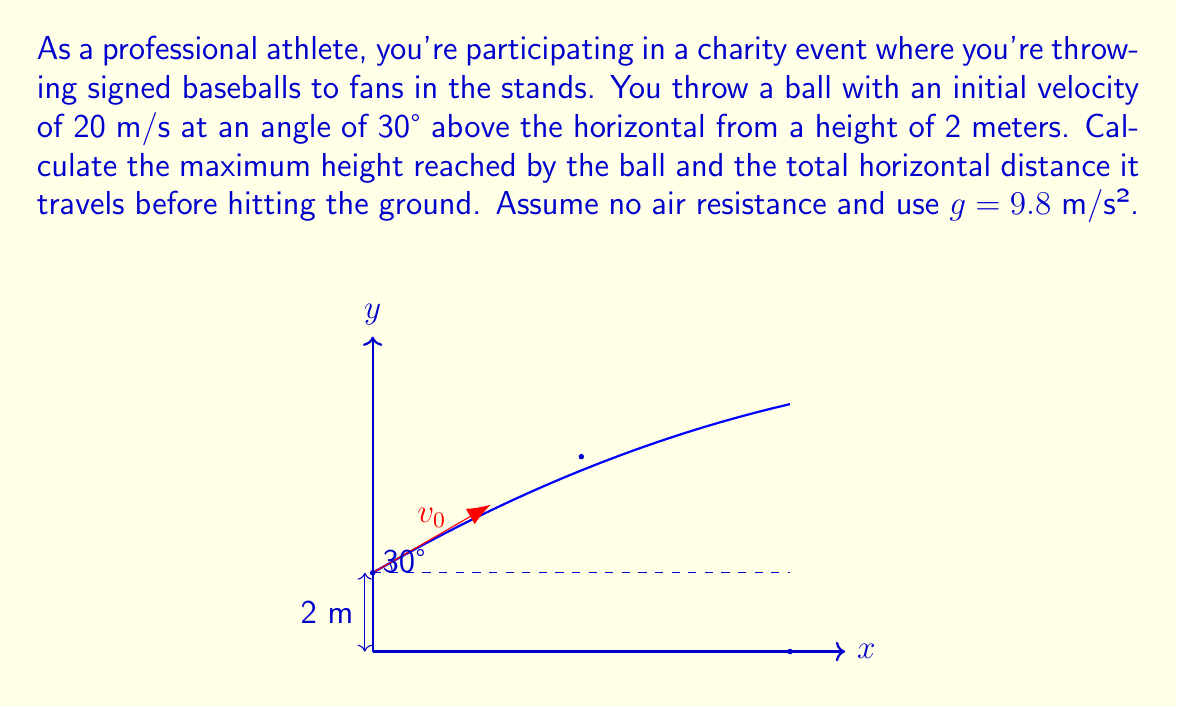Can you answer this question? Let's approach this problem step-by-step using vector components:

1) First, let's break down the initial velocity into its x and y components:
   $$v_{0x} = v_0 \cos \theta = 20 \cos 30° = 17.32 \text{ m/s}$$
   $$v_{0y} = v_0 \sin \theta = 20 \sin 30° = 10 \text{ m/s}$$

2) The time to reach maximum height can be calculated using the y-component:
   $$t_{max} = \frac{v_{0y}}{g} = \frac{10}{9.8} = 1.02 \text{ s}$$

3) The maximum height can be calculated using:
   $$h_{max} = h_0 + v_{0y}t - \frac{1}{2}gt^2$$
   where $h_0$ is the initial height (2 m)
   $$h_{max} = 2 + 10(1.02) - \frac{1}{2}(9.8)(1.02)^2 = 7.11 \text{ m}$$

4) The total time of flight is twice the time to reach maximum height:
   $$t_{total} = 2t_{max} = 2(1.02) = 2.04 \text{ s}$$

5) The horizontal distance can be calculated using the x-component of velocity:
   $$d = v_{0x}t_{total} = 17.32(2.04) = 35.33 \text{ m}$$

Therefore, the maximum height reached by the ball is 7.11 m (5.11 m above the initial height), and the total horizontal distance traveled is 35.33 m.
Answer: Maximum height: 7.11 m; Horizontal distance: 35.33 m 